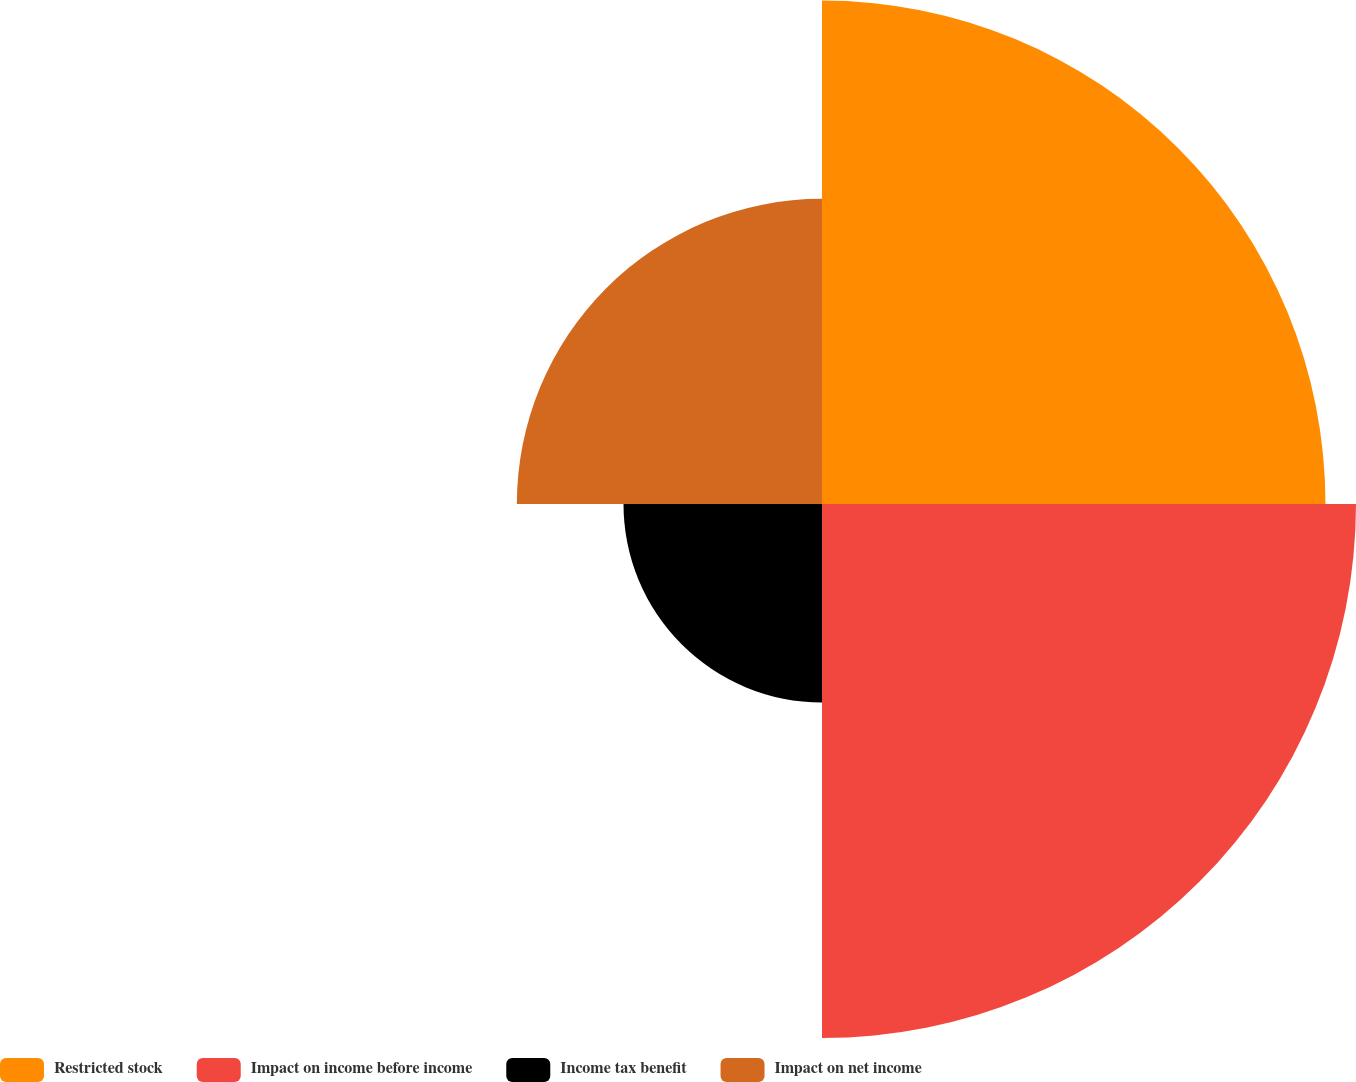Convert chart to OTSL. <chart><loc_0><loc_0><loc_500><loc_500><pie_chart><fcel>Restricted stock<fcel>Impact on income before income<fcel>Income tax benefit<fcel>Impact on net income<nl><fcel>32.67%<fcel>34.65%<fcel>12.88%<fcel>19.8%<nl></chart> 